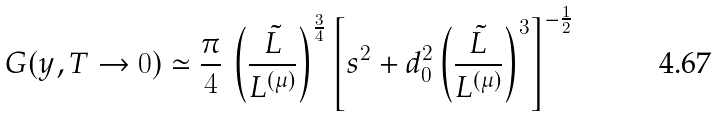Convert formula to latex. <formula><loc_0><loc_0><loc_500><loc_500>G ( y , T \to 0 ) \simeq { \frac { \pi } { 4 } } \, \left ( { \frac { \tilde { L } } { L ^ { ( \mu ) } } } \right ) ^ { \frac { 3 } { 4 } } \left [ s ^ { 2 } + d _ { 0 } ^ { 2 } \left ( { \frac { \tilde { L } } { L ^ { ( \mu ) } } } \right ) ^ { 3 } \right ] ^ { - { \frac { 1 } { 2 } } }</formula> 